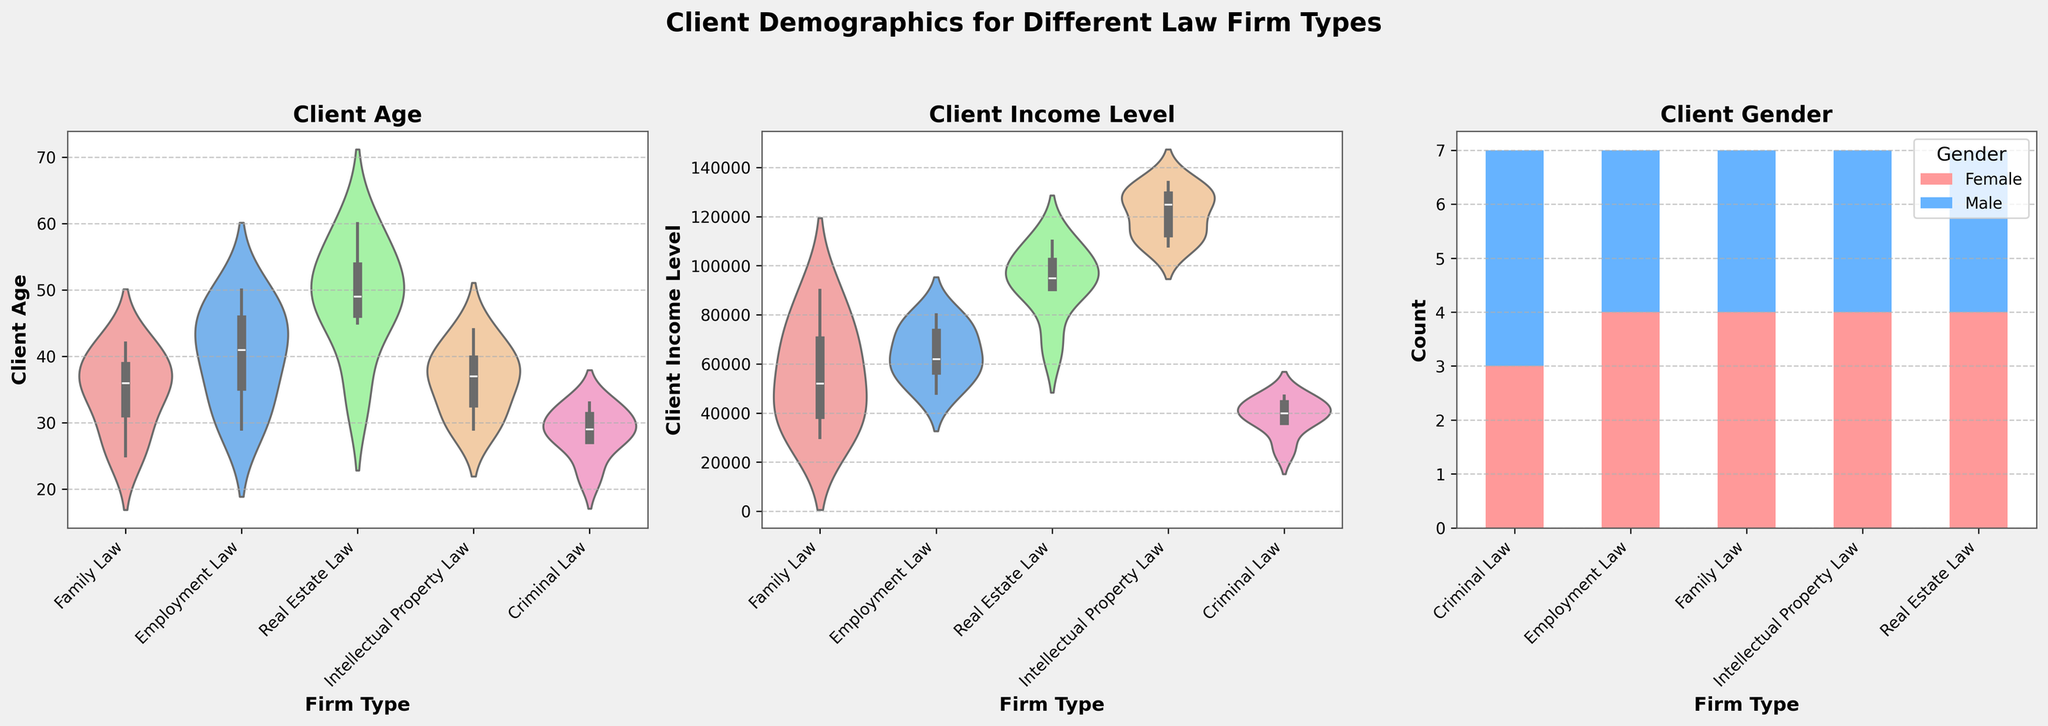What's the title of the figure? The title of the figure is placed above the entire figure and is usually large and bold. The title in this figure reads "Client Demographics for Different Law Firm Types".
Answer: Client Demographics for Different Law Firm Types How many subplots are there in the figure? The figure consists of three subplots arranged side by side. This can be easily observed by counting the distinct sections of the figure.
Answer: 3 Which firm type has the youngest client age on average? Looking at the 'Client Age' subplot, we observe that the median age of Criminal Law clients is the lowest among all the firm types. We can deduce this by noting the distribution shown by the violin plot.
Answer: Criminal Law What is the general distribution of income levels for Family Law clients compared to Intellectual Property Law clients? By examining the 'Client Income Level' violin plots for both Family Law and Intellectual Property Law clients, we see that Family Law clients tend to have a lower income range, clustered below $100,000, whereas Intellectual Property Law clients have a higher and broader income range, generally between $100,000 and $140,000.
Answer: Family Law clients have lower income levels than Intellectual Property Law clients Which gender is predominant for clients in Real Estate Law firms? The bar chart for 'Client Gender' shows grouped and stacked bars for each firm type. Real Estate Law has higher bars for female clients, indicating that most clients are female.
Answer: Female Are male clients more common in Employment Law than in Family Law? By comparing the bars for male clients in both Employment Law and Family Law subplots in the 'Client Gender' chart, we observe that Employment Law appears to have a comparable but slightly higher number of male clients than Family Law.
Answer: Yes Which firm type shows the greatest variability in client income levels? The 'Client Income Level' violin plot reveals the width and distribution spread of client income levels for each firm type. Intellectual Property Law has the widest plot, indicating the most variability in income levels.
Answer: Intellectual Property Law What is the range of ages for clients in Real Estate Law? In the 'Client Age' subplot, the violin plot for Real Estate Law spans from approximately 30 to 60, indicating that the range of ages for these clients is 30 to 60 years.
Answer: 30 to 60 years Name a firm type where male clients’ income levels do not exceed $50,000. In the 'Client Income Level' subplot, observing the sections for Criminal Law, male client incomes are consistently below $50,000.
Answer: Criminal Law 